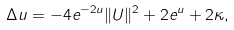Convert formula to latex. <formula><loc_0><loc_0><loc_500><loc_500>\Delta u = - 4 e ^ { - 2 u } \| U \| ^ { 2 } + 2 e ^ { u } + 2 \kappa ,</formula> 